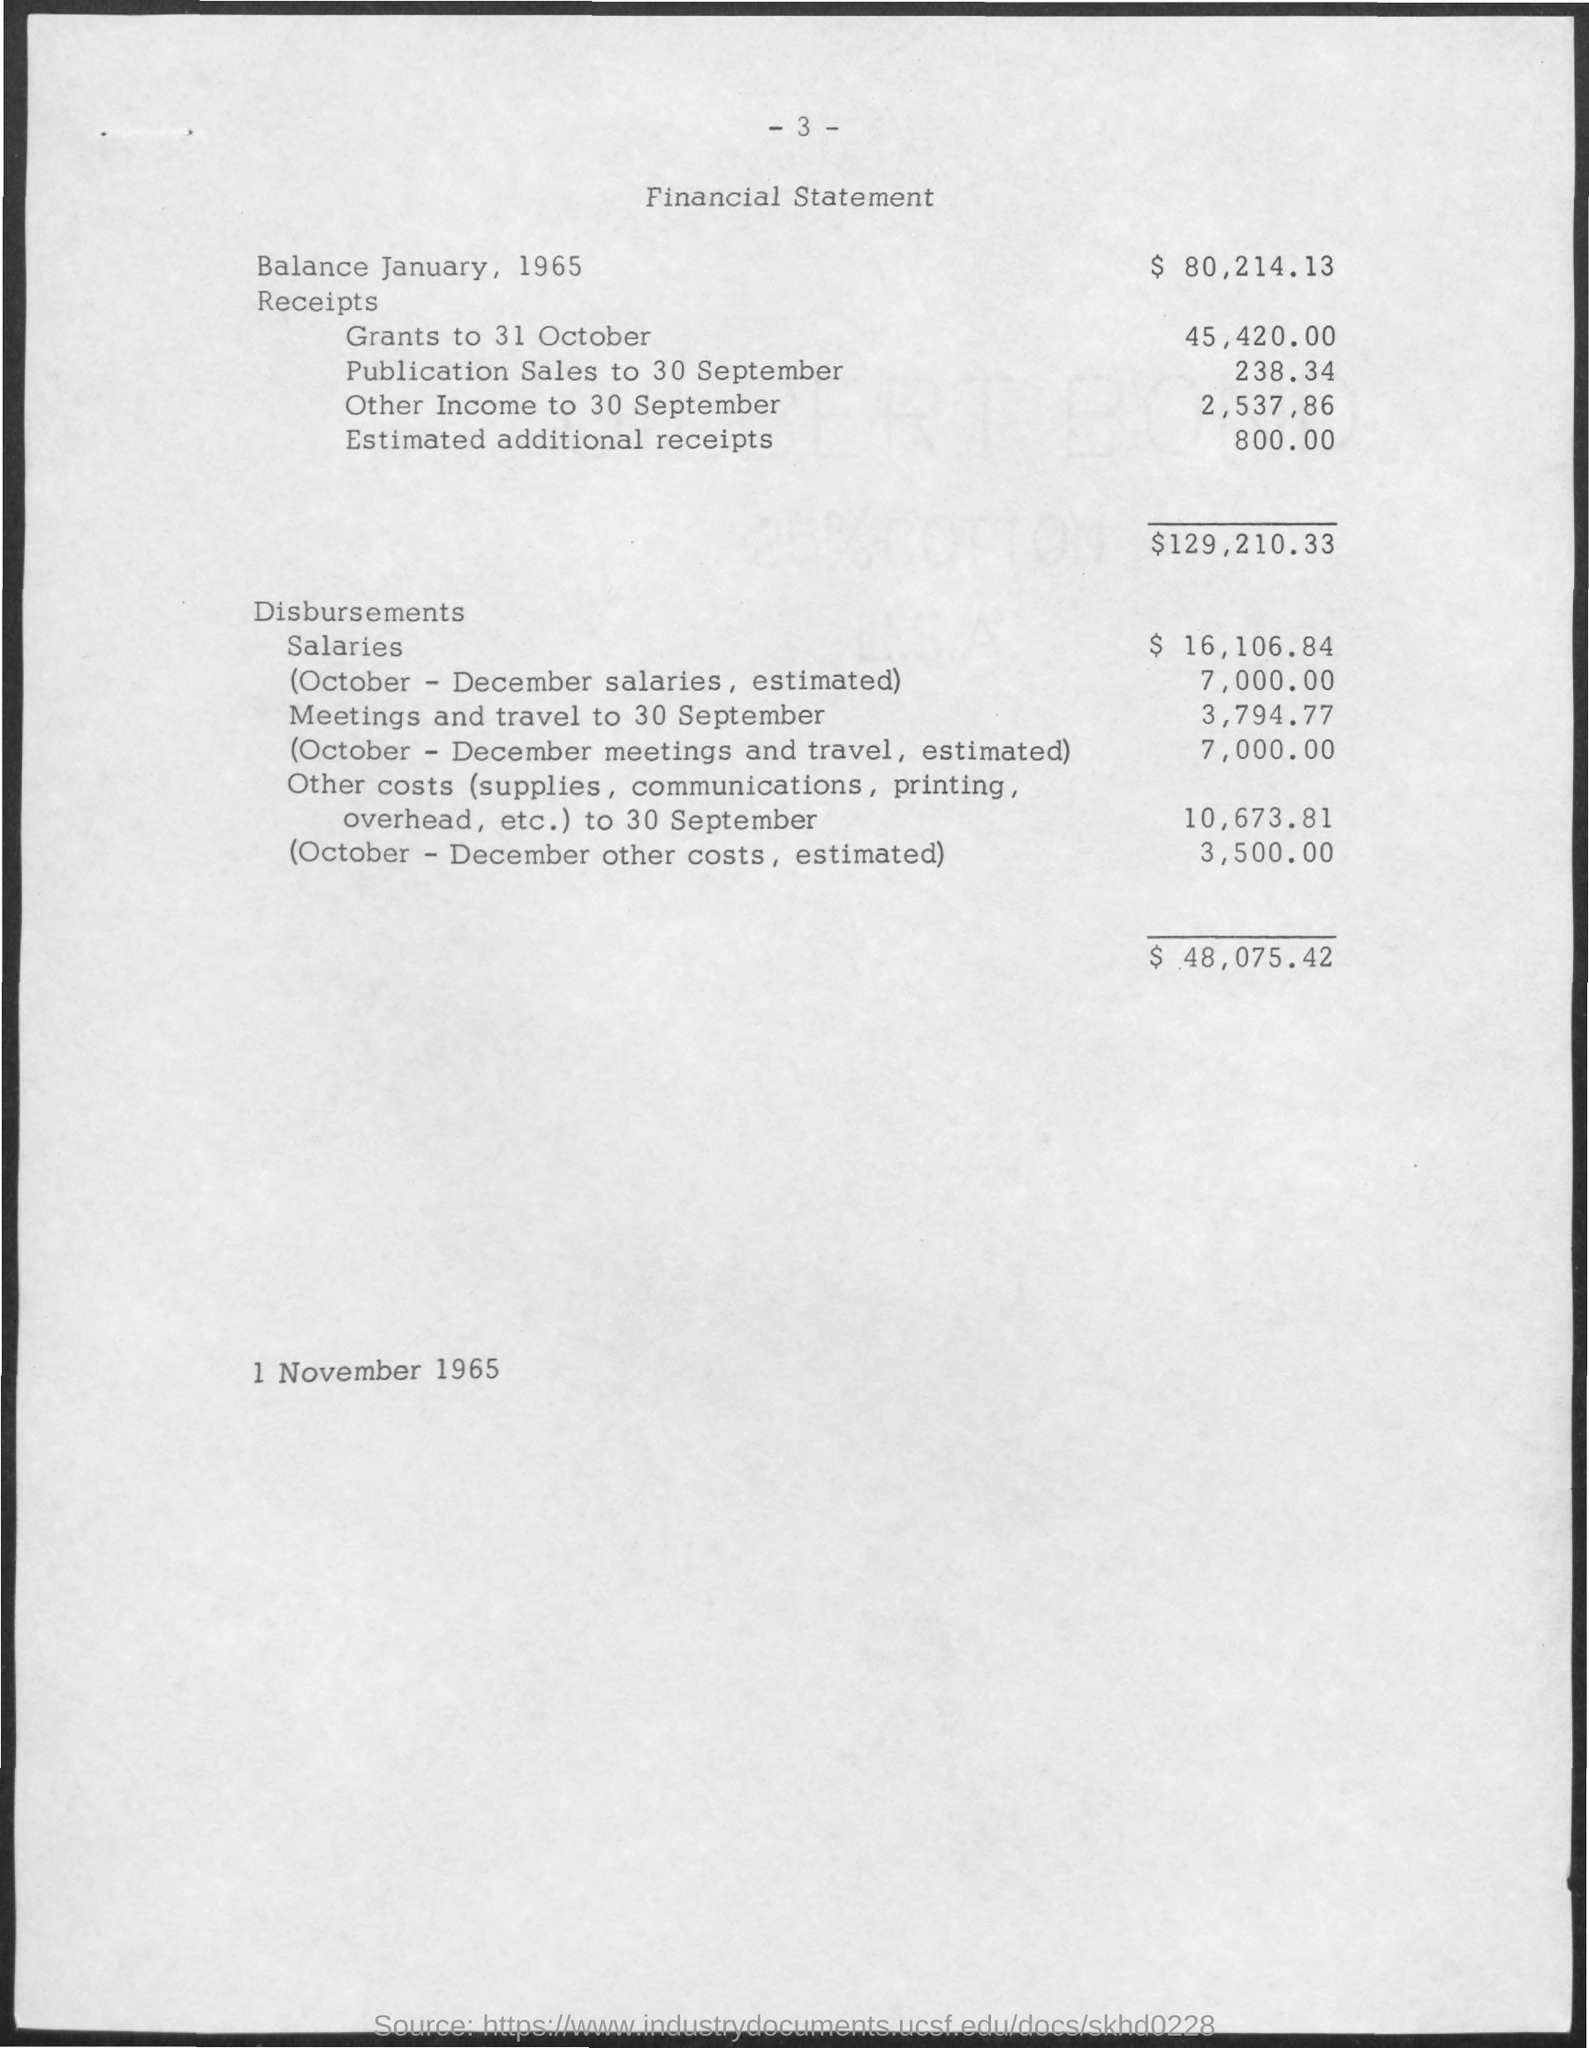What is the page number at top of the page?
Offer a terse response. 3. What is the title of the page?
Ensure brevity in your answer.  Financial statement. What is the balance on january, 1965?
Make the answer very short. 80,214.13. What is the total amount of receipts?
Provide a short and direct response. $129,210.33. What is the amount of salary in disbursements?
Ensure brevity in your answer.  $ 16,106.84. What is the total amount of disbursements ?
Your answer should be very brief. $ 48,075.42. What is the date at bottom of the page?
Offer a very short reply. 1 November 1965. What is the amount of grants to 31 october in receipts ?
Give a very brief answer. $45,420.00. What is the amount of publication sales to 30 september in receipts?
Your answer should be very brief. 238.34. What is the amount of estimated additional receipts in receipts ?
Give a very brief answer. 800. 